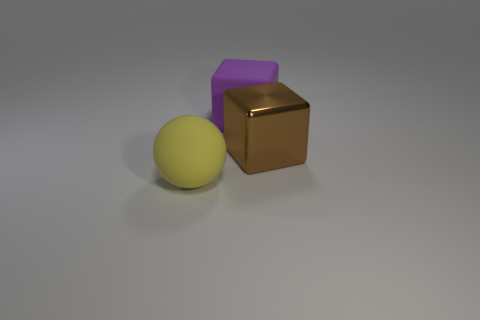What number of rubber objects are large red objects or spheres?
Your answer should be compact. 1. The big thing that is behind the large yellow rubber ball and to the left of the brown shiny object is what color?
Keep it short and to the point. Purple. How many matte cubes are in front of the purple cube?
Give a very brief answer. 0. What is the brown thing made of?
Provide a succinct answer. Metal. There is a big thing on the right side of the big matte object that is behind the big thing that is to the right of the big purple thing; what color is it?
Offer a very short reply. Brown. What number of other brown cubes are the same size as the matte cube?
Keep it short and to the point. 1. There is a big matte object on the right side of the rubber ball; what color is it?
Keep it short and to the point. Purple. What number of other objects are the same size as the metallic thing?
Your response must be concise. 2. How big is the thing that is in front of the large matte block and behind the big yellow rubber sphere?
Provide a succinct answer. Large. Is the color of the large ball the same as the large object behind the large brown block?
Provide a short and direct response. No. 